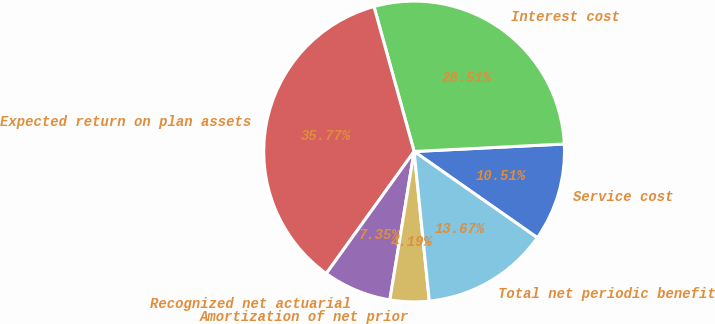<chart> <loc_0><loc_0><loc_500><loc_500><pie_chart><fcel>Service cost<fcel>Interest cost<fcel>Expected return on plan assets<fcel>Recognized net actuarial<fcel>Amortization of net prior<fcel>Total net periodic benefit<nl><fcel>10.51%<fcel>28.51%<fcel>35.77%<fcel>7.35%<fcel>4.19%<fcel>13.67%<nl></chart> 